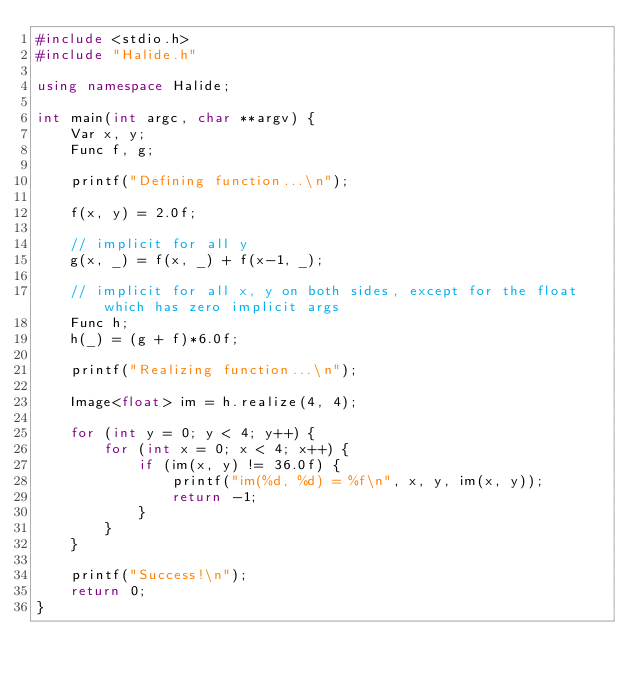<code> <loc_0><loc_0><loc_500><loc_500><_C++_>#include <stdio.h>
#include "Halide.h"

using namespace Halide;

int main(int argc, char **argv) {
    Var x, y;
    Func f, g;

    printf("Defining function...\n");

    f(x, y) = 2.0f;

    // implicit for all y
    g(x, _) = f(x, _) + f(x-1, _);

    // implicit for all x, y on both sides, except for the float which has zero implicit args
    Func h;
    h(_) = (g + f)*6.0f;

    printf("Realizing function...\n");

    Image<float> im = h.realize(4, 4);

    for (int y = 0; y < 4; y++) {
        for (int x = 0; x < 4; x++) {
            if (im(x, y) != 36.0f) {
                printf("im(%d, %d) = %f\n", x, y, im(x, y));
                return -1;
            }
        }
    }

    printf("Success!\n");
    return 0;
}
</code> 